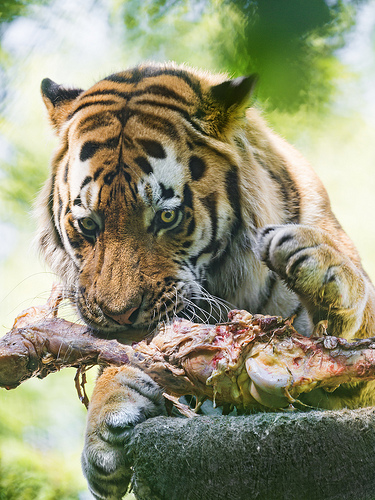<image>
Is the paw above the snout? Yes. The paw is positioned above the snout in the vertical space, higher up in the scene. 